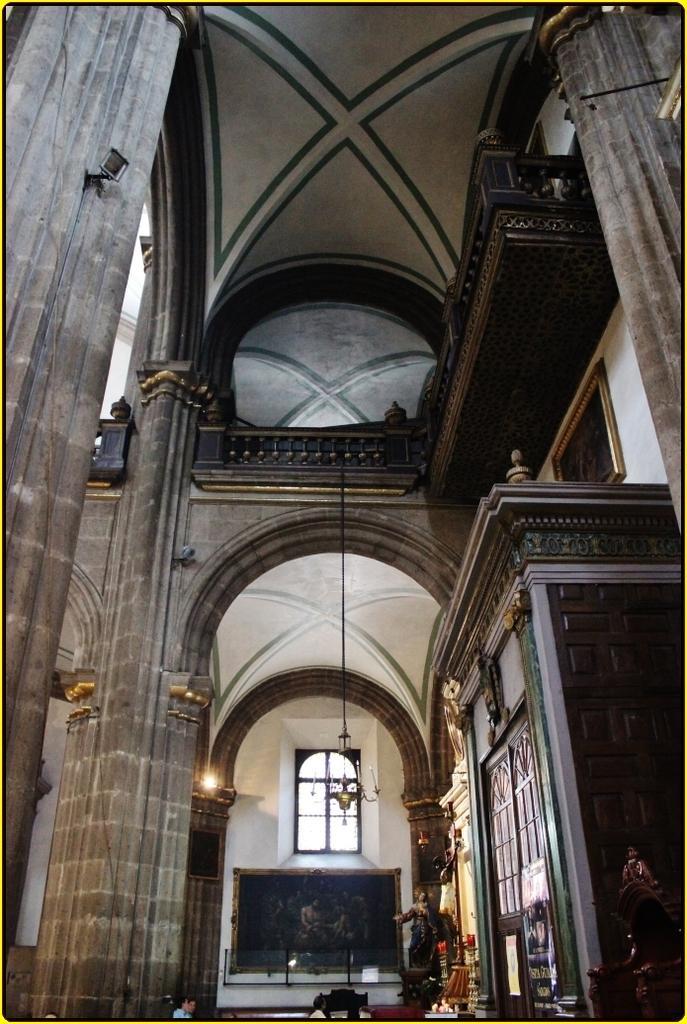Describe this image in one or two sentences. The image is taken inside the building. At the center there are statues and wall frame. At the top there is a chandelier. On the right there is a pillar. 